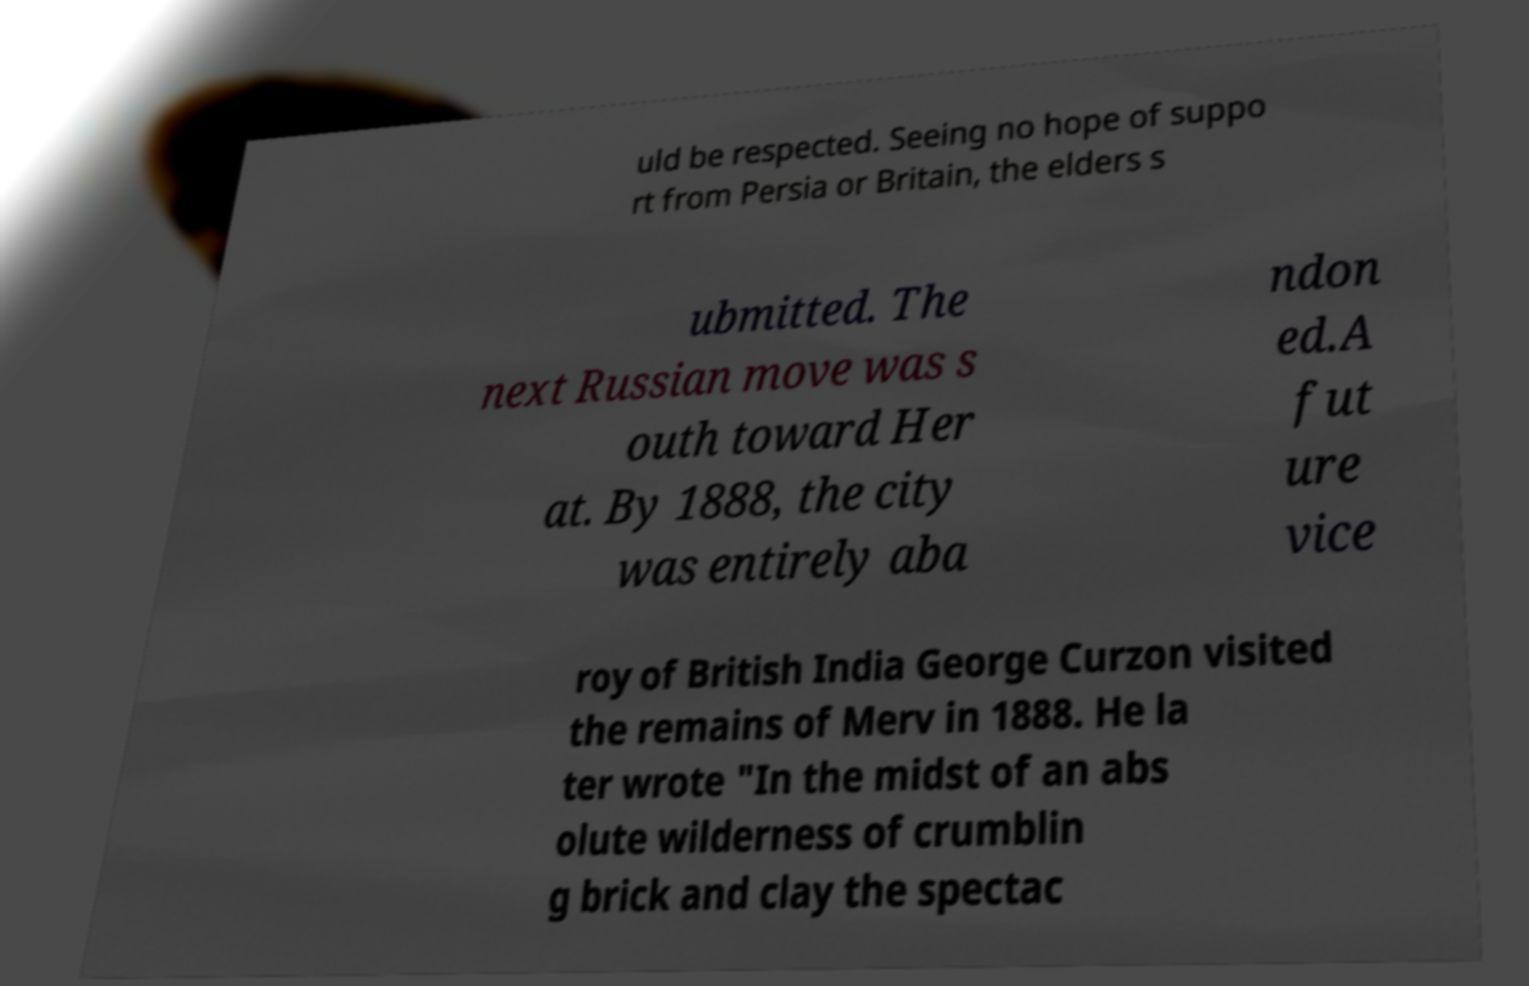There's text embedded in this image that I need extracted. Can you transcribe it verbatim? uld be respected. Seeing no hope of suppo rt from Persia or Britain, the elders s ubmitted. The next Russian move was s outh toward Her at. By 1888, the city was entirely aba ndon ed.A fut ure vice roy of British India George Curzon visited the remains of Merv in 1888. He la ter wrote "In the midst of an abs olute wilderness of crumblin g brick and clay the spectac 